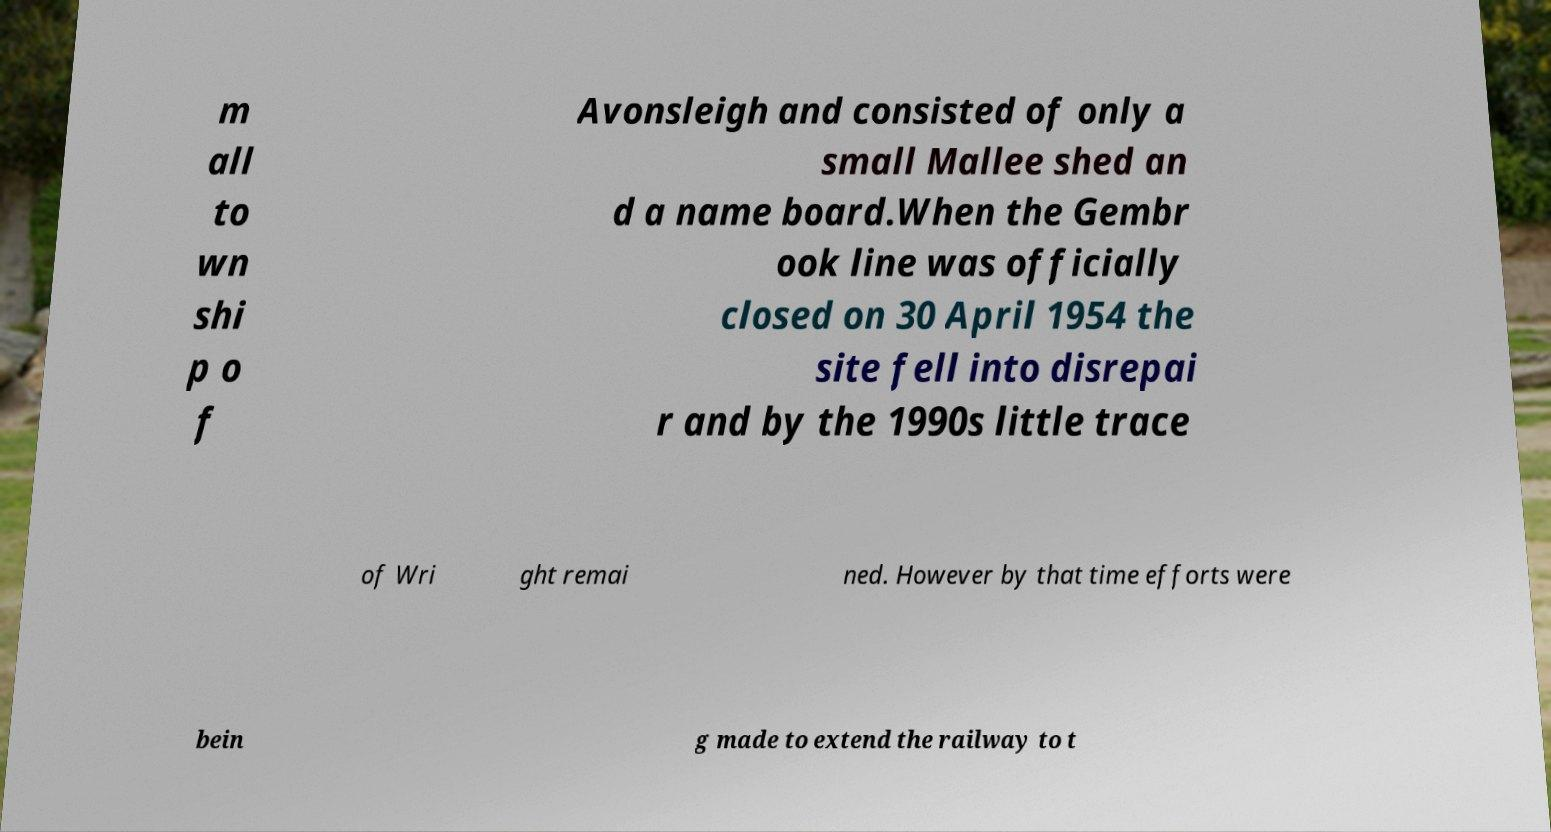For documentation purposes, I need the text within this image transcribed. Could you provide that? m all to wn shi p o f Avonsleigh and consisted of only a small Mallee shed an d a name board.When the Gembr ook line was officially closed on 30 April 1954 the site fell into disrepai r and by the 1990s little trace of Wri ght remai ned. However by that time efforts were bein g made to extend the railway to t 